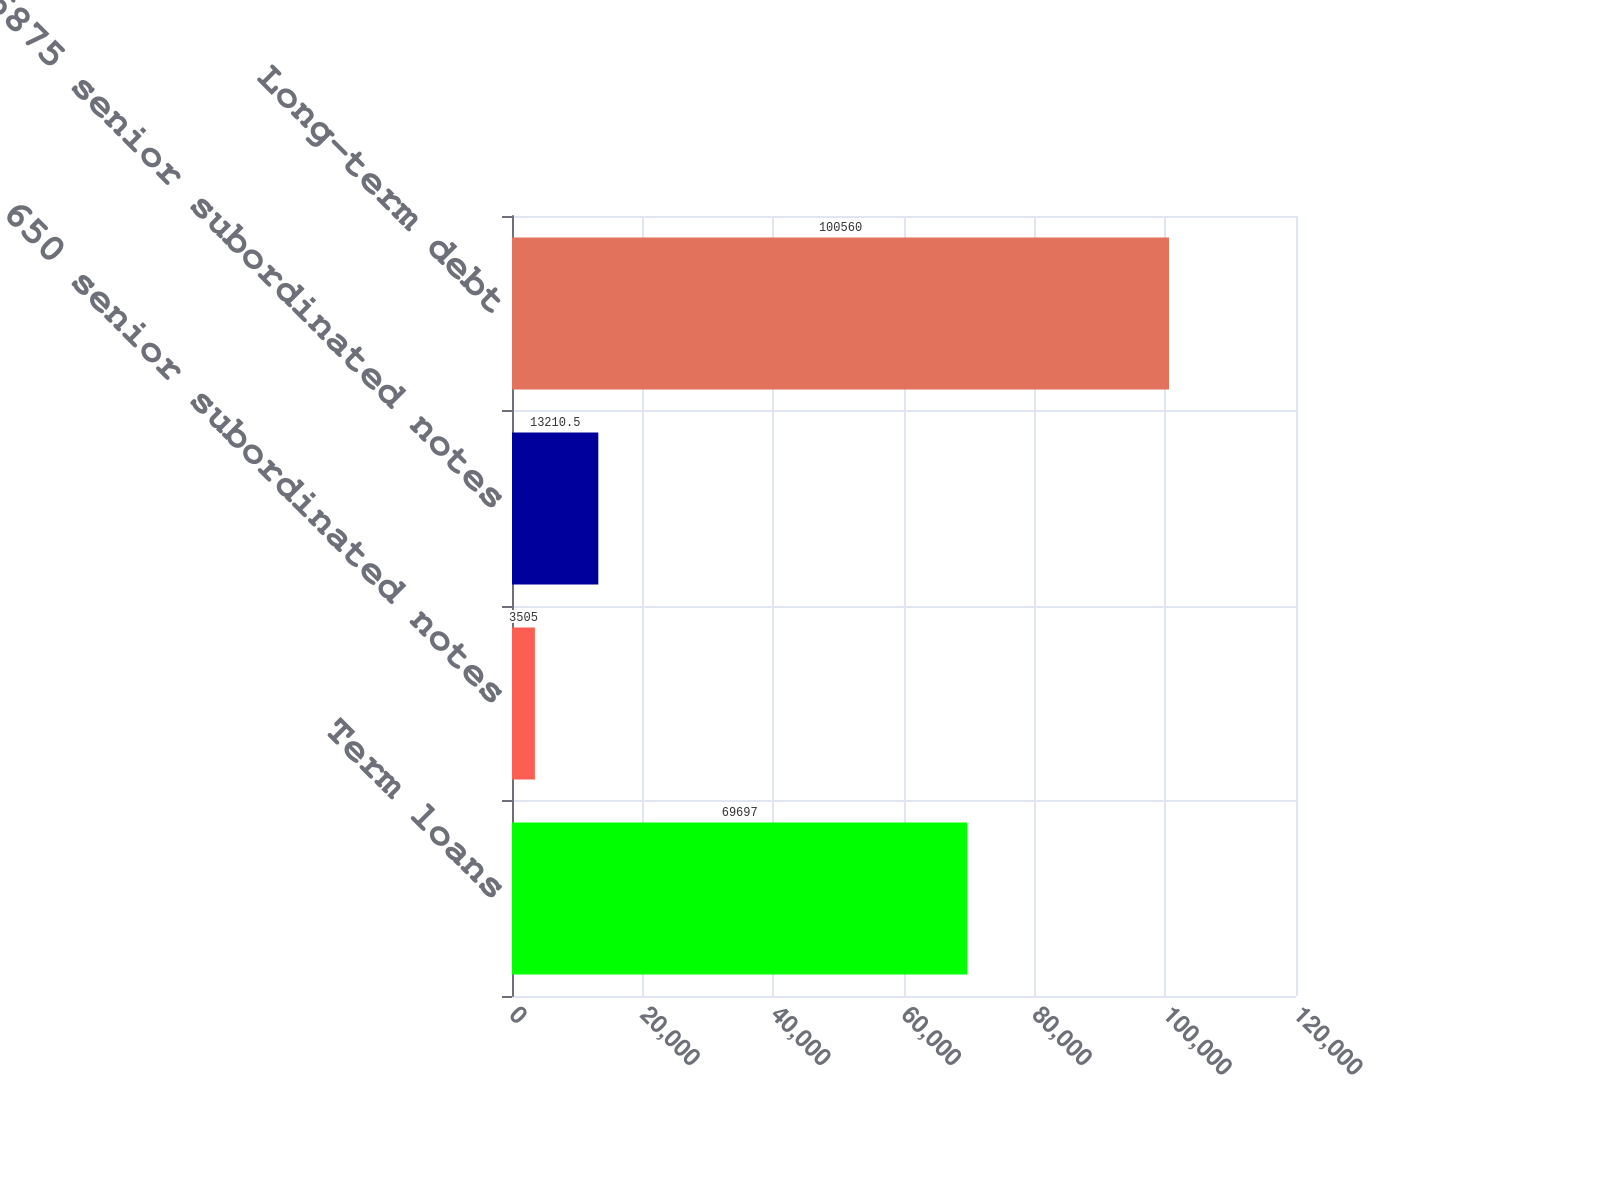Convert chart. <chart><loc_0><loc_0><loc_500><loc_500><bar_chart><fcel>Term loans<fcel>650 senior subordinated notes<fcel>6875 senior subordinated notes<fcel>Long-term debt<nl><fcel>69697<fcel>3505<fcel>13210.5<fcel>100560<nl></chart> 